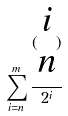Convert formula to latex. <formula><loc_0><loc_0><loc_500><loc_500>\sum _ { i = n } ^ { m } \frac { ( \begin{matrix} i \\ n \end{matrix} ) } { 2 ^ { i } }</formula> 